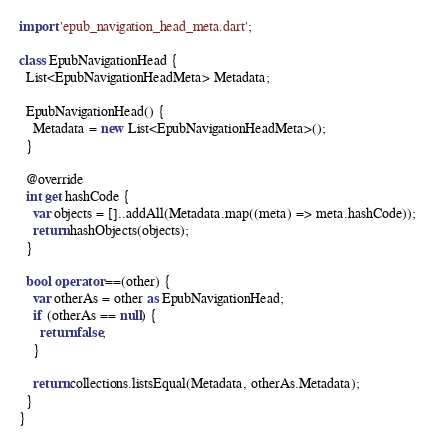Convert code to text. <code><loc_0><loc_0><loc_500><loc_500><_Dart_>
import 'epub_navigation_head_meta.dart';

class EpubNavigationHead {
  List<EpubNavigationHeadMeta> Metadata;

  EpubNavigationHead() {
    Metadata = new List<EpubNavigationHeadMeta>();
  }

  @override
  int get hashCode {
    var objects = []..addAll(Metadata.map((meta) => meta.hashCode));
    return hashObjects(objects);
  }

  bool operator ==(other) {
    var otherAs = other as EpubNavigationHead;
    if (otherAs == null) {
      return false;
    }

    return collections.listsEqual(Metadata, otherAs.Metadata);
  }
}
</code> 